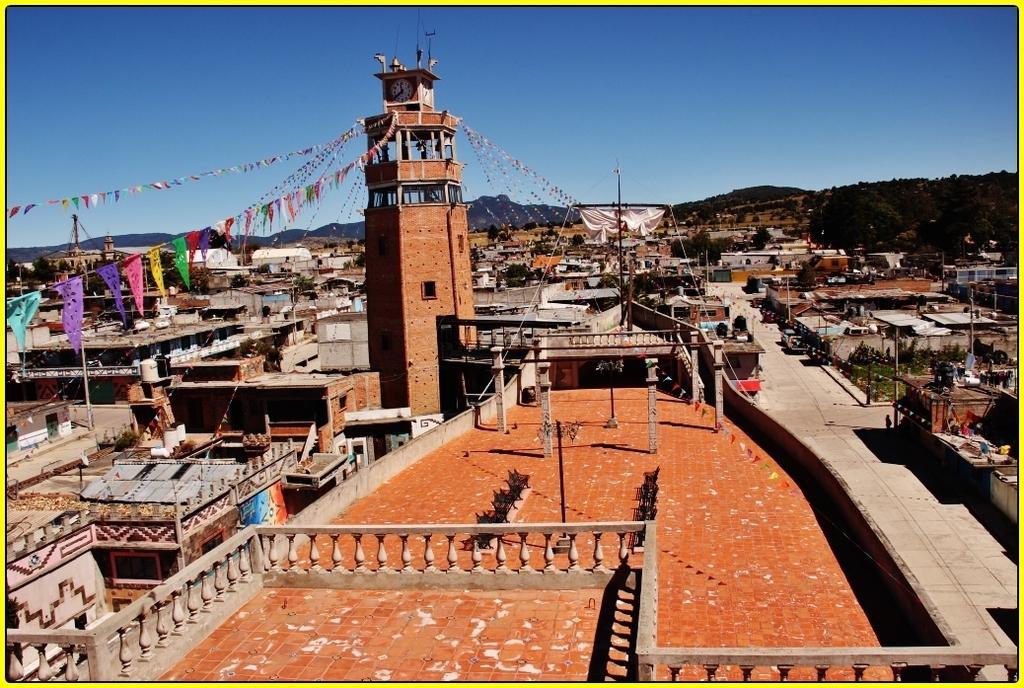Describe this image in one or two sentences. In this image there are buildings, there are decorative flags from a clock tower, there are roads, trees, electric towers with cables on it, objects and mountains. 